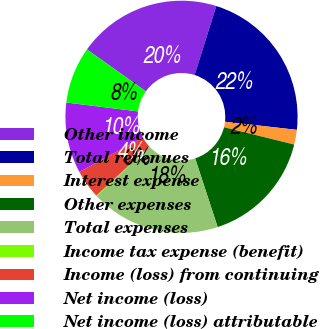Convert chart. <chart><loc_0><loc_0><loc_500><loc_500><pie_chart><fcel>Other income<fcel>Total revenues<fcel>Interest expense<fcel>Other expenses<fcel>Total expenses<fcel>Income tax expense (benefit)<fcel>Income (loss) from continuing<fcel>Net income (loss)<fcel>Net income (loss) attributable<nl><fcel>20.0%<fcel>21.95%<fcel>2.05%<fcel>16.11%<fcel>18.06%<fcel>0.1%<fcel>4.0%<fcel>9.84%<fcel>7.89%<nl></chart> 